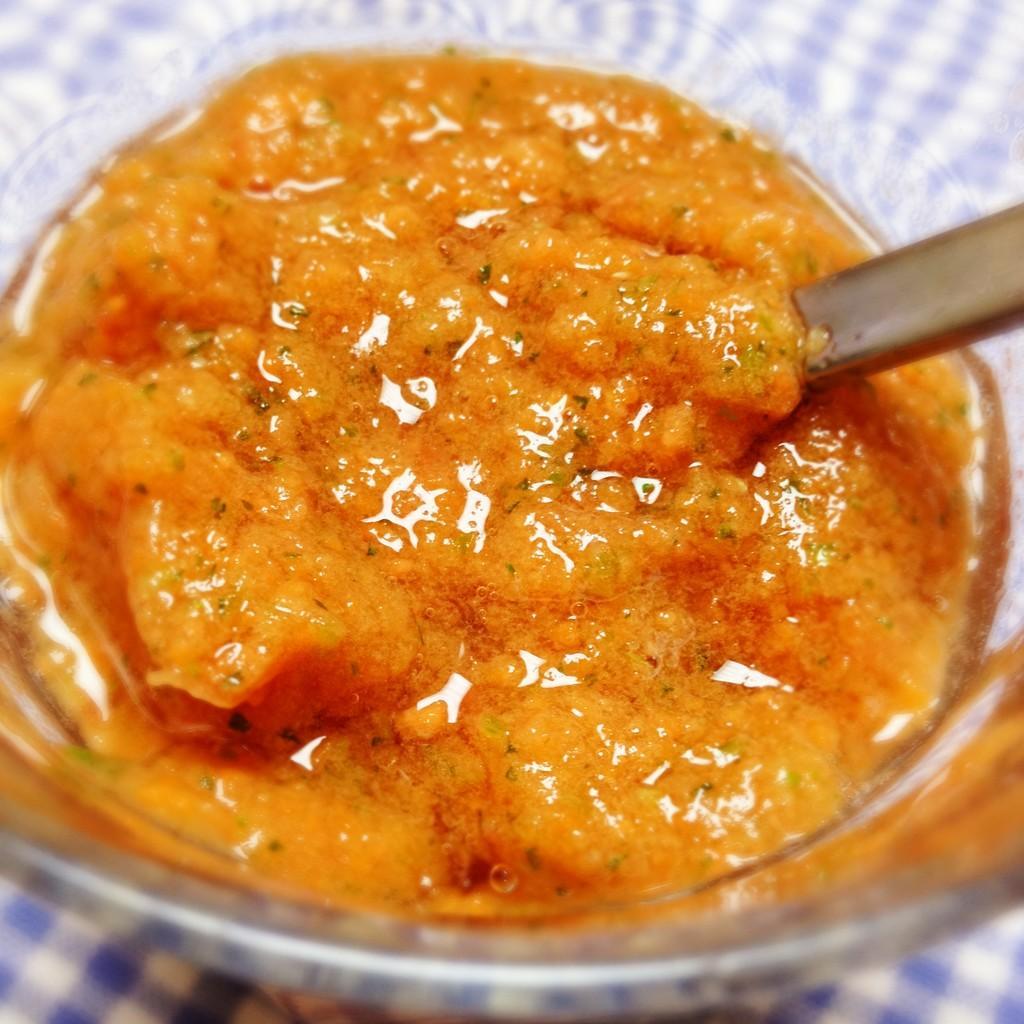Please provide a concise description of this image. In the image in the center, we can see one table. On the table, we can see one cloth and bowl. In the bowl, we can see one spoon and some food items. 